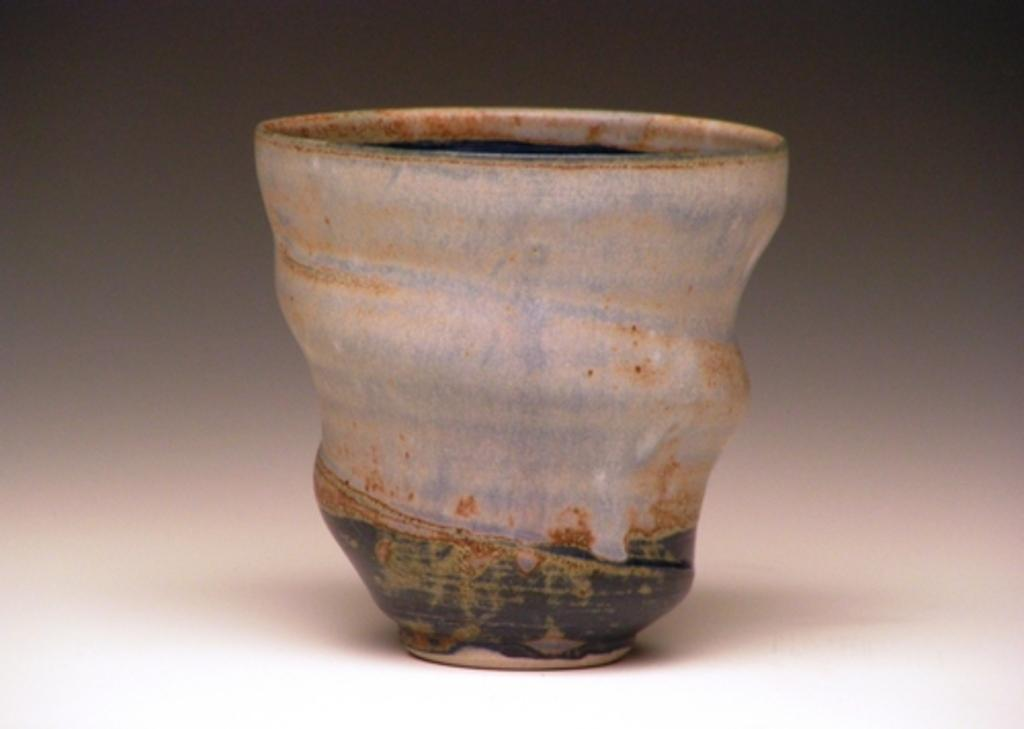What object is present in the image? There is a flower pot in the image. What is the flower pot placed on? The flower pot is on a white surface. What type of flag is being waved by the father at the school in the image? There is no flag, father, or school present in the image; it only features a flower pot on a white surface. 